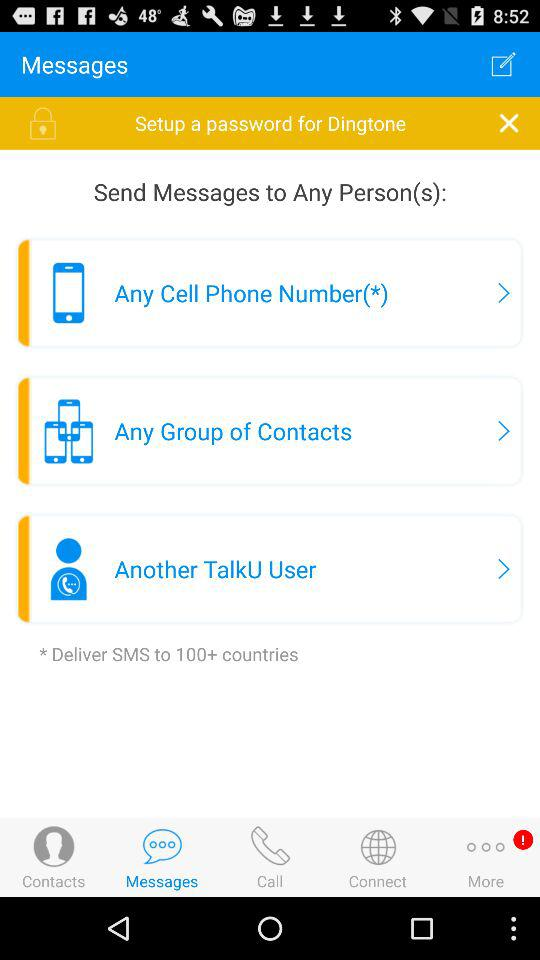In how many countries can SMS be delivered? SMS can be delivered in 100+ countries. 